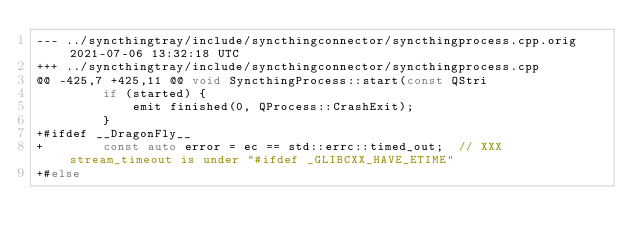<code> <loc_0><loc_0><loc_500><loc_500><_C++_>--- ../syncthingtray/include/syncthingconnector/syncthingprocess.cpp.orig	2021-07-06 13:32:18 UTC
+++ ../syncthingtray/include/syncthingconnector/syncthingprocess.cpp
@@ -425,7 +425,11 @@ void SyncthingProcess::start(const QStri
         if (started) {
             emit finished(0, QProcess::CrashExit);
         }
+#ifdef __DragonFly__
+        const auto error = ec == std::errc::timed_out;  // XXX stream_timeout is under "#ifdef _GLIBCXX_HAVE_ETIME"
+#else</code> 